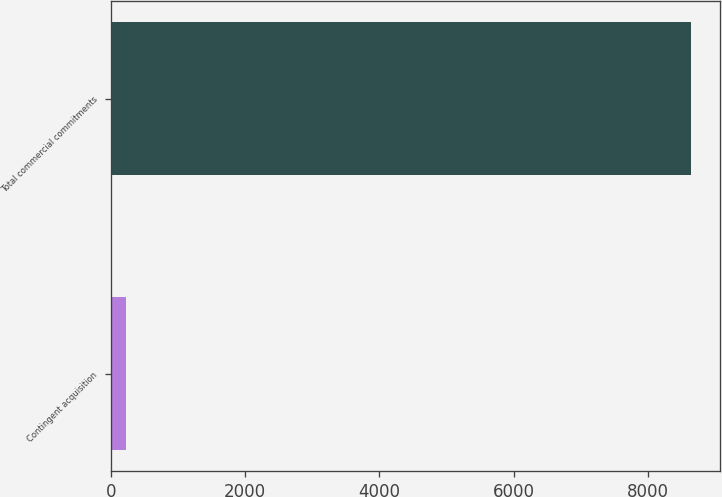Convert chart. <chart><loc_0><loc_0><loc_500><loc_500><bar_chart><fcel>Contingent acquisition<fcel>Total commercial commitments<nl><fcel>227<fcel>8638<nl></chart> 